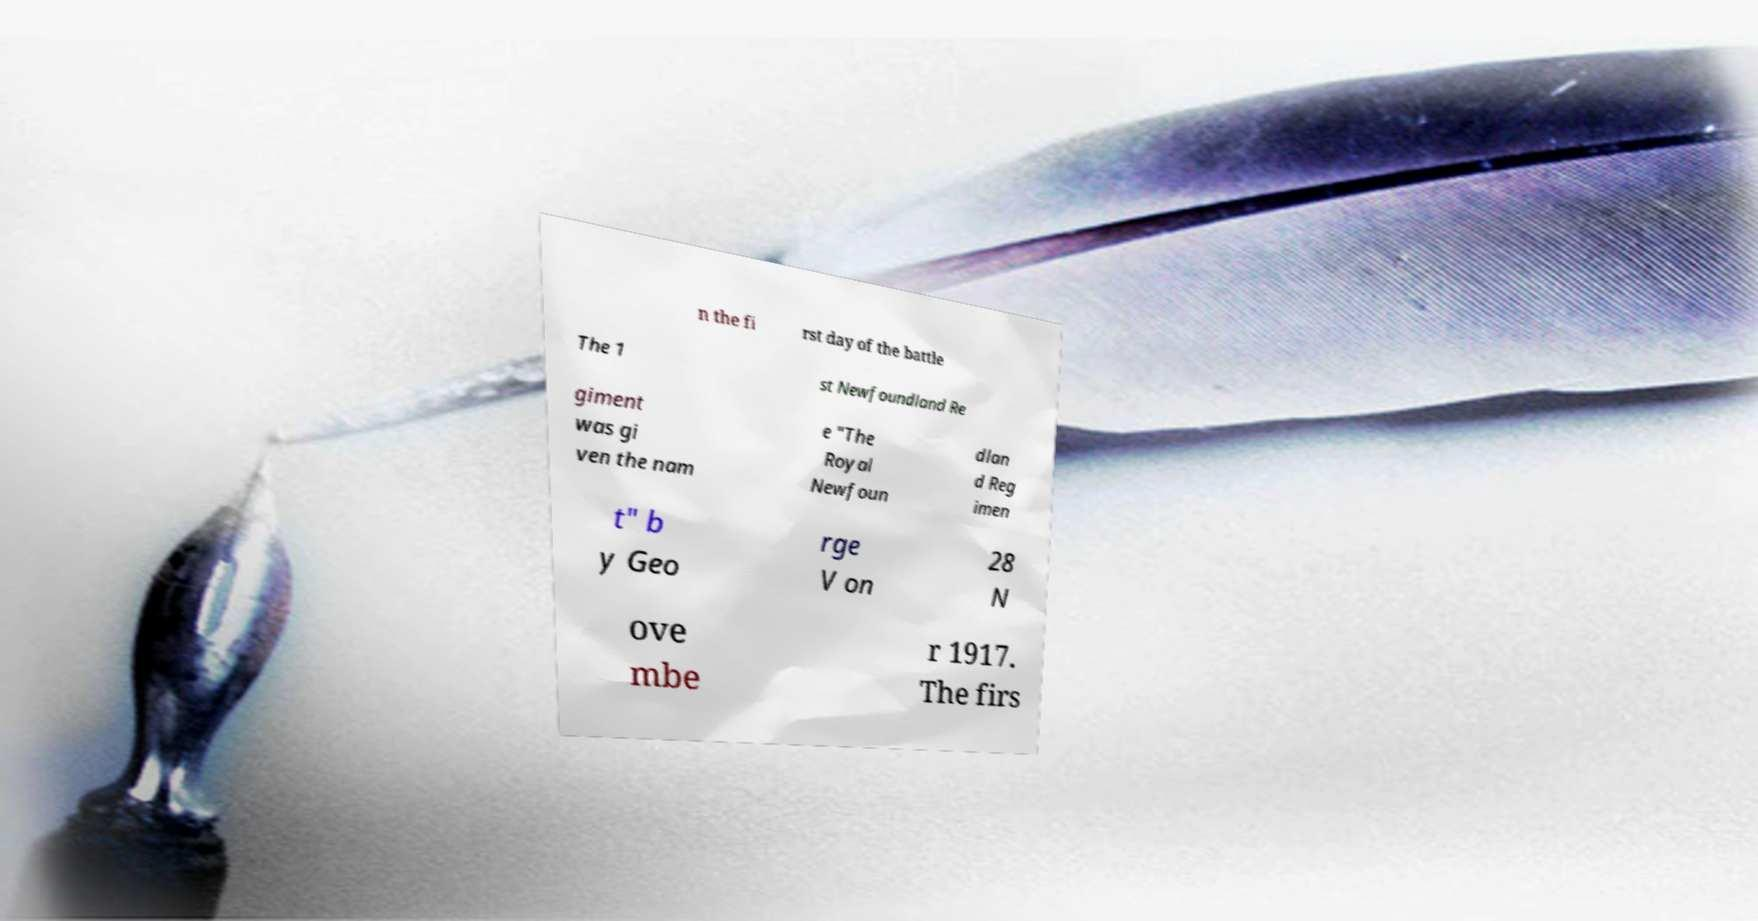Please read and relay the text visible in this image. What does it say? n the fi rst day of the battle The 1 st Newfoundland Re giment was gi ven the nam e "The Royal Newfoun dlan d Reg imen t" b y Geo rge V on 28 N ove mbe r 1917. The firs 